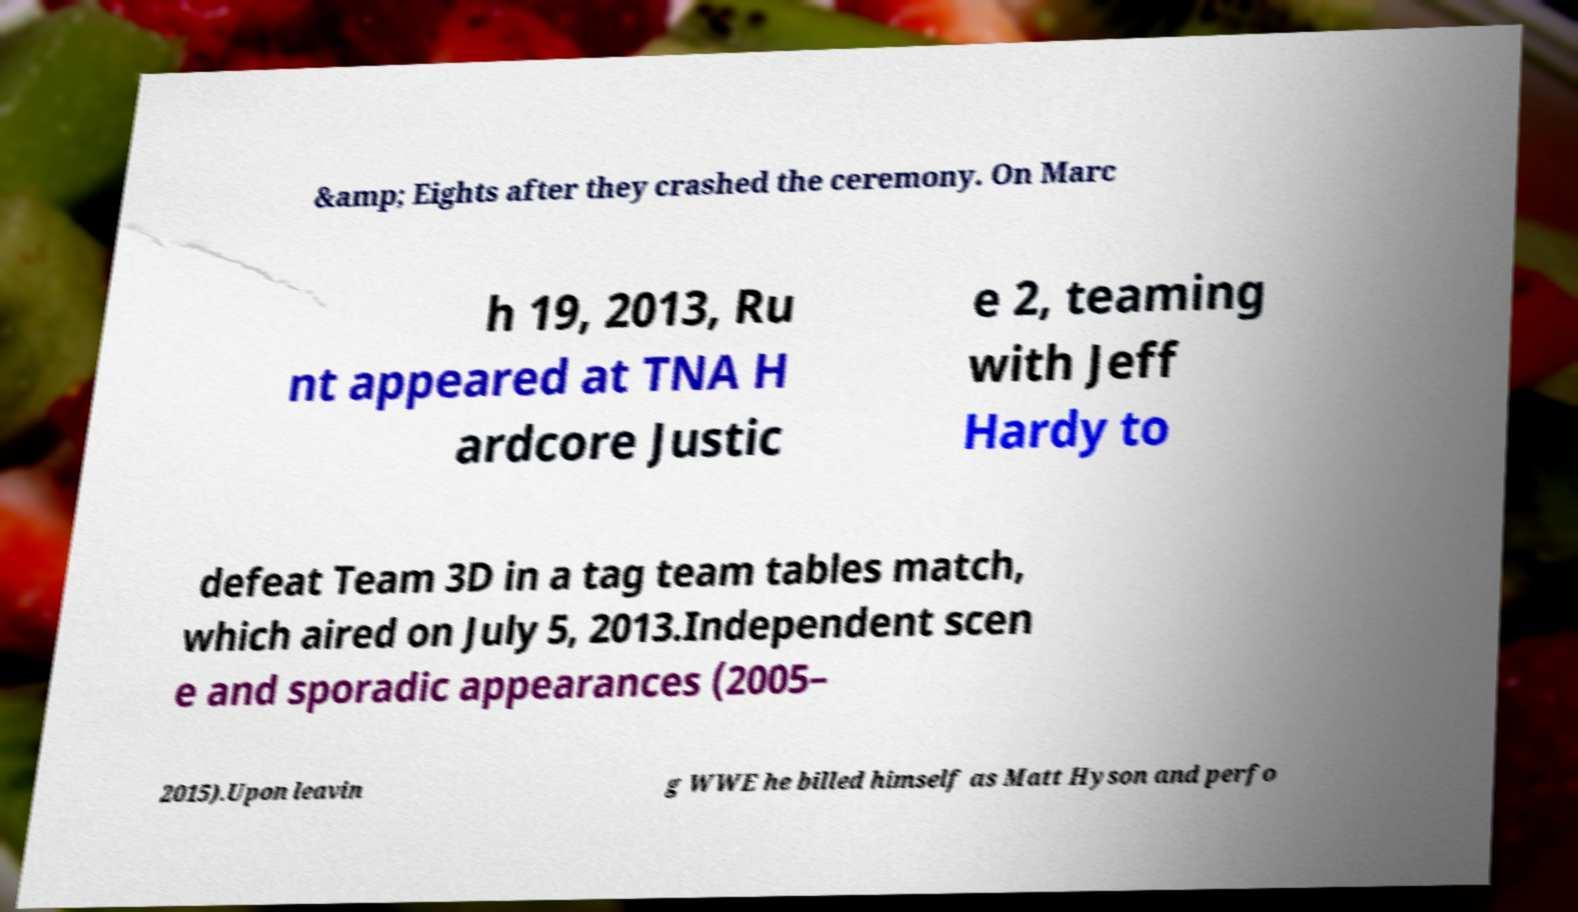For documentation purposes, I need the text within this image transcribed. Could you provide that? &amp; Eights after they crashed the ceremony. On Marc h 19, 2013, Ru nt appeared at TNA H ardcore Justic e 2, teaming with Jeff Hardy to defeat Team 3D in a tag team tables match, which aired on July 5, 2013.Independent scen e and sporadic appearances (2005– 2015).Upon leavin g WWE he billed himself as Matt Hyson and perfo 